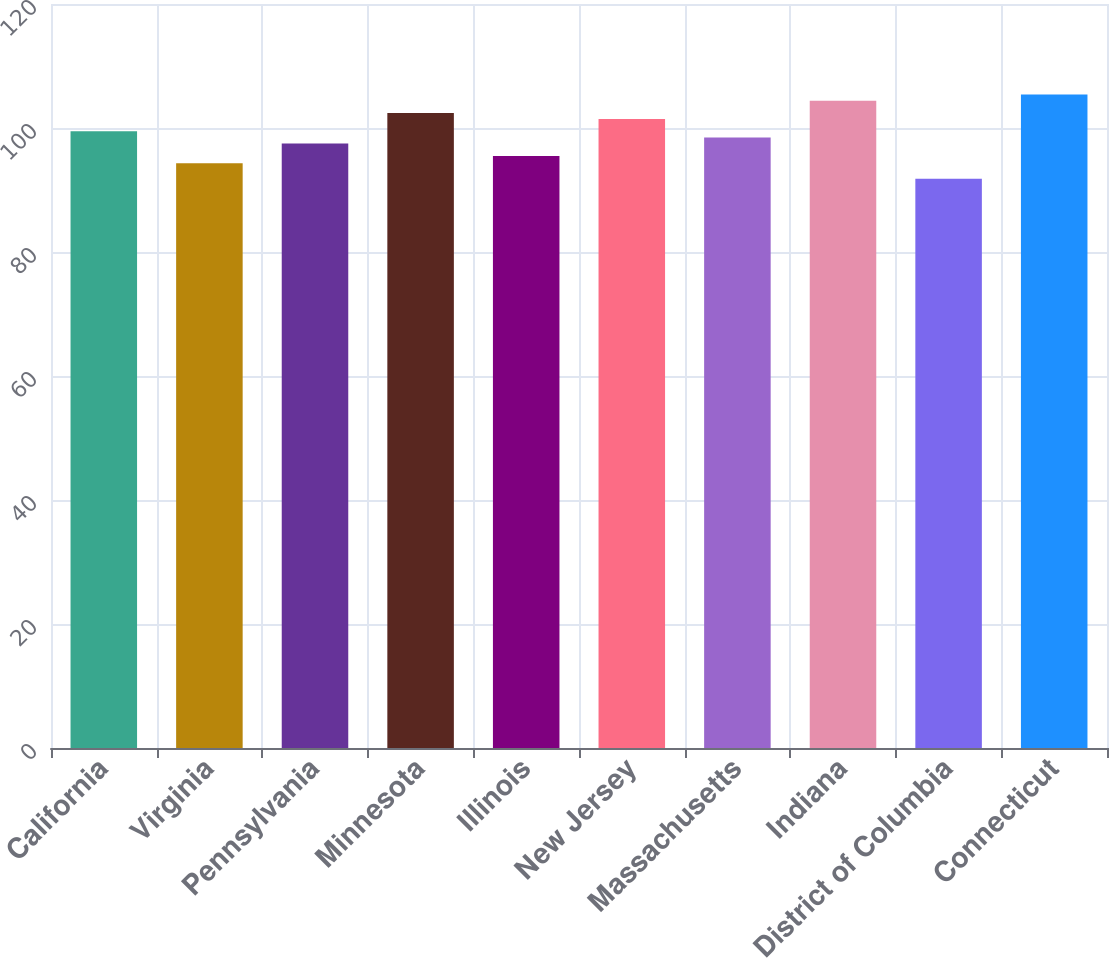Convert chart. <chart><loc_0><loc_0><loc_500><loc_500><bar_chart><fcel>California<fcel>Virginia<fcel>Pennsylvania<fcel>Minnesota<fcel>Illinois<fcel>New Jersey<fcel>Massachusetts<fcel>Indiana<fcel>District of Columbia<fcel>Connecticut<nl><fcel>99.46<fcel>94.3<fcel>97.48<fcel>102.43<fcel>95.5<fcel>101.44<fcel>98.47<fcel>104.41<fcel>91.8<fcel>105.4<nl></chart> 